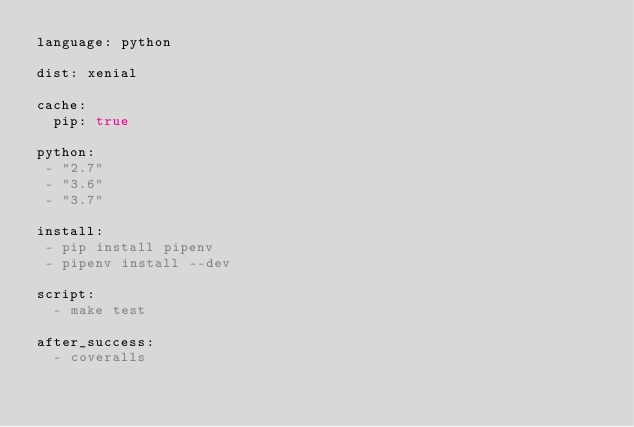Convert code to text. <code><loc_0><loc_0><loc_500><loc_500><_YAML_>language: python

dist: xenial

cache:
  pip: true

python:
 - "2.7"
 - "3.6"
 - "3.7"

install:
 - pip install pipenv
 - pipenv install --dev

script:
  - make test

after_success:
  - coveralls
</code> 